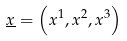<formula> <loc_0><loc_0><loc_500><loc_500>\underline { x } = \left ( x ^ { 1 } , x ^ { 2 } , x ^ { 3 } \right )</formula> 